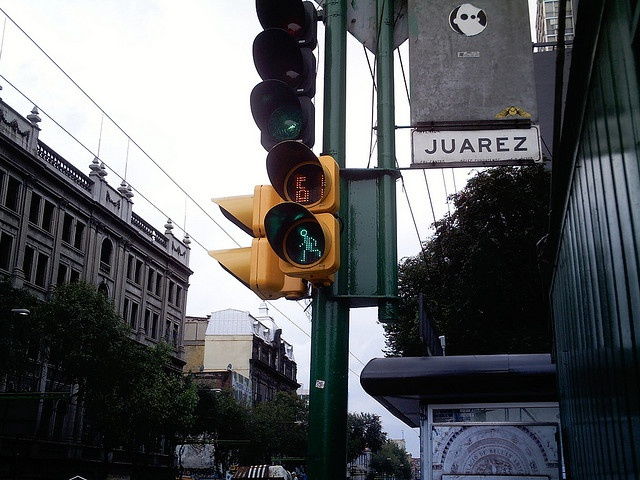Describe the objects in this image and their specific colors. I can see traffic light in white, black, and gray tones and traffic light in white, black, brown, and maroon tones in this image. 